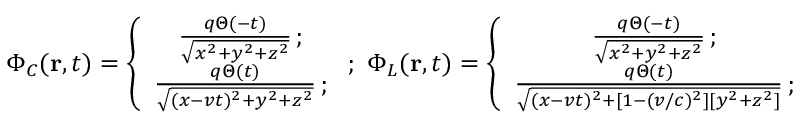<formula> <loc_0><loc_0><loc_500><loc_500>\Phi _ { C } ( { r } , t ) = \left \{ \begin{array} { c c c } { \frac { q \Theta ( - t ) } { \sqrt { x ^ { 2 } + y ^ { 2 } + z ^ { 2 } } } \, ; } \\ { \frac { q \Theta ( t ) } { \sqrt { ( x - v t ) ^ { 2 } + y ^ { 2 } + z ^ { 2 } } } \, ; } \end{array} ; \, \Phi _ { L } ( { r } , t ) = \left \{ \begin{array} { c c c } { \frac { q \Theta ( - t ) } { \sqrt { x ^ { 2 } + y ^ { 2 } + z ^ { 2 } } } \, ; } \\ { \frac { q \Theta ( t ) } { \sqrt { ( x - v t ) ^ { 2 } + [ 1 - ( v / c ) ^ { 2 } ] [ y ^ { 2 } + z ^ { 2 } ] } } \, ; } \end{array}</formula> 